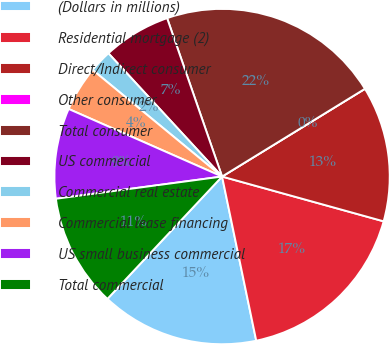Convert chart. <chart><loc_0><loc_0><loc_500><loc_500><pie_chart><fcel>(Dollars in millions)<fcel>Residential mortgage (2)<fcel>Direct/Indirect consumer<fcel>Other consumer<fcel>Total consumer<fcel>US commercial<fcel>Commercial real estate<fcel>Commercial lease financing<fcel>US small business commercial<fcel>Total commercial<nl><fcel>15.25%<fcel>17.43%<fcel>13.07%<fcel>0.0%<fcel>21.55%<fcel>6.54%<fcel>2.18%<fcel>4.36%<fcel>8.72%<fcel>10.9%<nl></chart> 